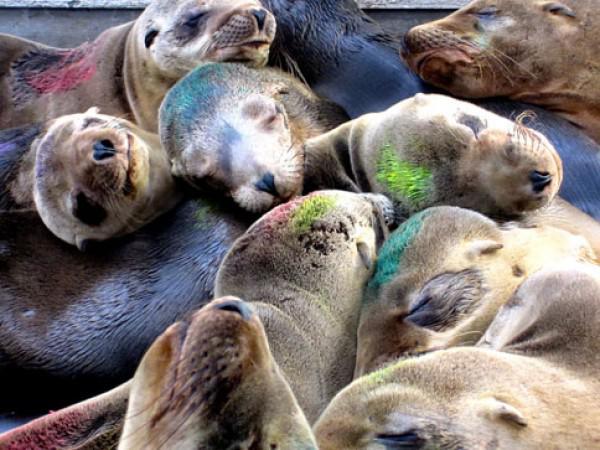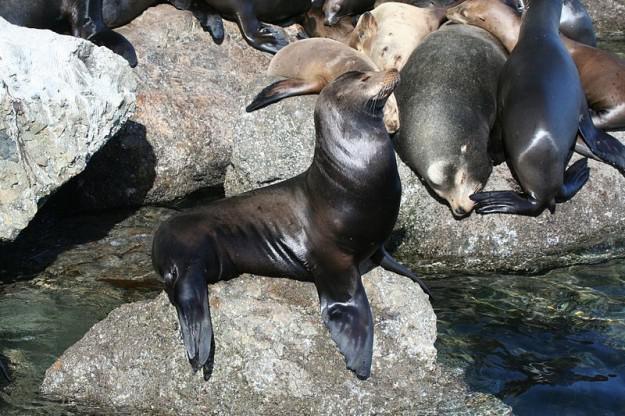The first image is the image on the left, the second image is the image on the right. For the images displayed, is the sentence "An image contains no more than one seal." factually correct? Answer yes or no. No. The first image is the image on the left, the second image is the image on the right. Evaluate the accuracy of this statement regarding the images: "Some of the sea lions have markings made by humans on them.". Is it true? Answer yes or no. Yes. 